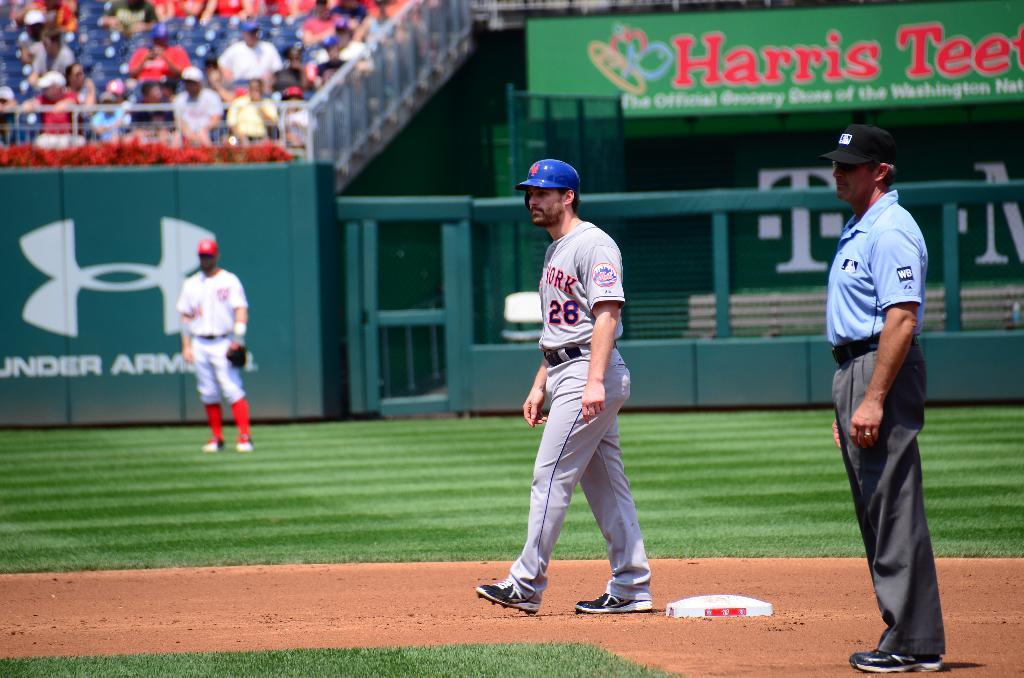<image>
Give a short and clear explanation of the subsequent image. A gray uniform wearing baseball player is standing at a base with the number 26 on his mid section. 